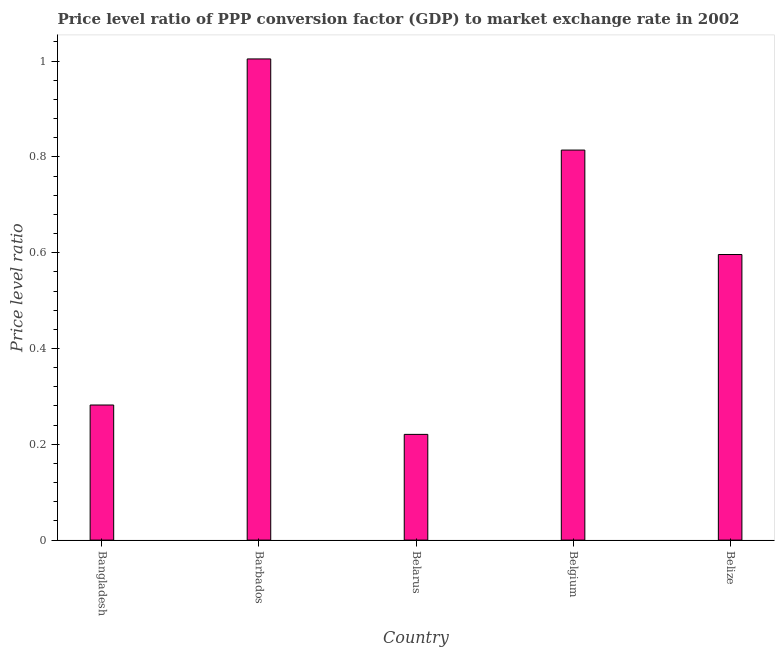Does the graph contain any zero values?
Make the answer very short. No. Does the graph contain grids?
Keep it short and to the point. No. What is the title of the graph?
Offer a very short reply. Price level ratio of PPP conversion factor (GDP) to market exchange rate in 2002. What is the label or title of the X-axis?
Offer a terse response. Country. What is the label or title of the Y-axis?
Provide a succinct answer. Price level ratio. What is the price level ratio in Belarus?
Provide a short and direct response. 0.22. Across all countries, what is the maximum price level ratio?
Give a very brief answer. 1. Across all countries, what is the minimum price level ratio?
Provide a succinct answer. 0.22. In which country was the price level ratio maximum?
Offer a terse response. Barbados. In which country was the price level ratio minimum?
Provide a short and direct response. Belarus. What is the sum of the price level ratio?
Offer a terse response. 2.92. What is the difference between the price level ratio in Bangladesh and Barbados?
Provide a short and direct response. -0.72. What is the average price level ratio per country?
Your response must be concise. 0.58. What is the median price level ratio?
Ensure brevity in your answer.  0.6. What is the ratio of the price level ratio in Barbados to that in Belarus?
Give a very brief answer. 4.55. Is the difference between the price level ratio in Bangladesh and Barbados greater than the difference between any two countries?
Ensure brevity in your answer.  No. What is the difference between the highest and the second highest price level ratio?
Provide a succinct answer. 0.19. What is the difference between the highest and the lowest price level ratio?
Offer a very short reply. 0.78. How many bars are there?
Give a very brief answer. 5. Are all the bars in the graph horizontal?
Offer a terse response. No. How many countries are there in the graph?
Provide a short and direct response. 5. Are the values on the major ticks of Y-axis written in scientific E-notation?
Keep it short and to the point. No. What is the Price level ratio of Bangladesh?
Keep it short and to the point. 0.28. What is the Price level ratio in Barbados?
Your response must be concise. 1. What is the Price level ratio in Belarus?
Your answer should be compact. 0.22. What is the Price level ratio of Belgium?
Ensure brevity in your answer.  0.81. What is the Price level ratio of Belize?
Ensure brevity in your answer.  0.6. What is the difference between the Price level ratio in Bangladesh and Barbados?
Keep it short and to the point. -0.72. What is the difference between the Price level ratio in Bangladesh and Belarus?
Your response must be concise. 0.06. What is the difference between the Price level ratio in Bangladesh and Belgium?
Your answer should be compact. -0.53. What is the difference between the Price level ratio in Bangladesh and Belize?
Offer a very short reply. -0.31. What is the difference between the Price level ratio in Barbados and Belarus?
Make the answer very short. 0.78. What is the difference between the Price level ratio in Barbados and Belgium?
Offer a terse response. 0.19. What is the difference between the Price level ratio in Barbados and Belize?
Provide a succinct answer. 0.41. What is the difference between the Price level ratio in Belarus and Belgium?
Your answer should be compact. -0.59. What is the difference between the Price level ratio in Belarus and Belize?
Keep it short and to the point. -0.38. What is the difference between the Price level ratio in Belgium and Belize?
Provide a short and direct response. 0.22. What is the ratio of the Price level ratio in Bangladesh to that in Barbados?
Your answer should be compact. 0.28. What is the ratio of the Price level ratio in Bangladesh to that in Belarus?
Make the answer very short. 1.28. What is the ratio of the Price level ratio in Bangladesh to that in Belgium?
Offer a terse response. 0.35. What is the ratio of the Price level ratio in Bangladesh to that in Belize?
Make the answer very short. 0.47. What is the ratio of the Price level ratio in Barbados to that in Belarus?
Your response must be concise. 4.55. What is the ratio of the Price level ratio in Barbados to that in Belgium?
Provide a short and direct response. 1.23. What is the ratio of the Price level ratio in Barbados to that in Belize?
Provide a succinct answer. 1.69. What is the ratio of the Price level ratio in Belarus to that in Belgium?
Your answer should be very brief. 0.27. What is the ratio of the Price level ratio in Belarus to that in Belize?
Your response must be concise. 0.37. What is the ratio of the Price level ratio in Belgium to that in Belize?
Offer a terse response. 1.37. 